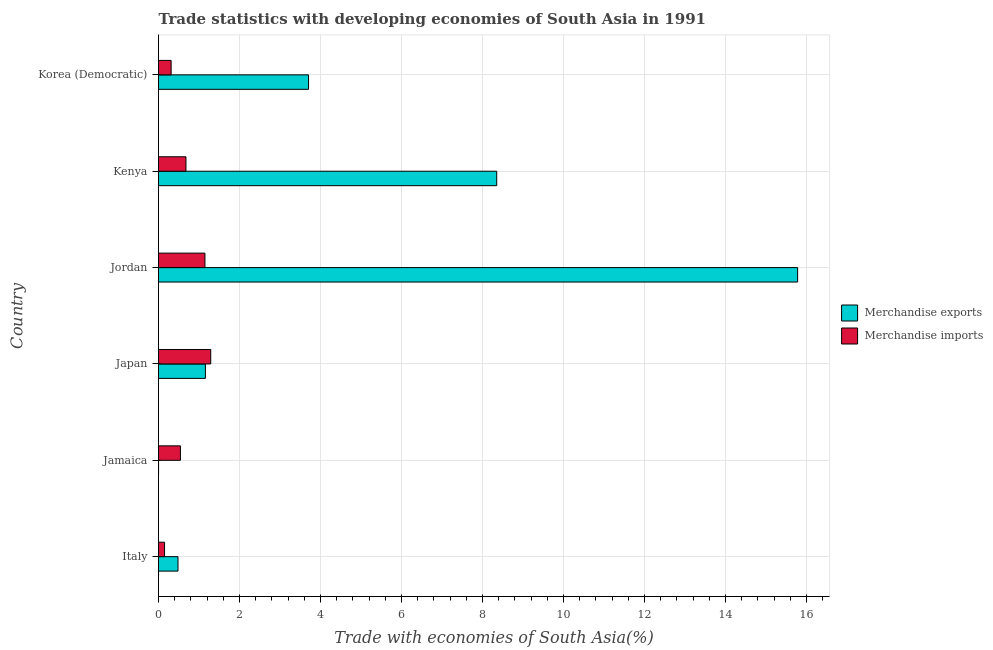How many different coloured bars are there?
Provide a succinct answer. 2. How many groups of bars are there?
Provide a succinct answer. 6. Are the number of bars on each tick of the Y-axis equal?
Your answer should be very brief. Yes. What is the label of the 4th group of bars from the top?
Your answer should be very brief. Japan. What is the merchandise exports in Jordan?
Offer a very short reply. 15.78. Across all countries, what is the maximum merchandise imports?
Your answer should be very brief. 1.29. Across all countries, what is the minimum merchandise exports?
Your answer should be very brief. 0. In which country was the merchandise imports maximum?
Give a very brief answer. Japan. In which country was the merchandise exports minimum?
Give a very brief answer. Jamaica. What is the total merchandise exports in the graph?
Your answer should be very brief. 29.48. What is the difference between the merchandise imports in Italy and that in Japan?
Offer a very short reply. -1.14. What is the difference between the merchandise exports in Japan and the merchandise imports in Italy?
Provide a succinct answer. 1.01. What is the average merchandise exports per country?
Provide a short and direct response. 4.91. What is the difference between the merchandise imports and merchandise exports in Jordan?
Offer a terse response. -14.63. What is the ratio of the merchandise exports in Jordan to that in Korea (Democratic)?
Give a very brief answer. 4.26. Is the difference between the merchandise imports in Italy and Jordan greater than the difference between the merchandise exports in Italy and Jordan?
Offer a very short reply. Yes. What is the difference between the highest and the second highest merchandise imports?
Offer a very short reply. 0.14. What is the difference between the highest and the lowest merchandise imports?
Ensure brevity in your answer.  1.14. In how many countries, is the merchandise exports greater than the average merchandise exports taken over all countries?
Make the answer very short. 2. What does the 2nd bar from the top in Jordan represents?
Keep it short and to the point. Merchandise exports. What does the 1st bar from the bottom in Kenya represents?
Offer a very short reply. Merchandise exports. How many bars are there?
Offer a terse response. 12. How many countries are there in the graph?
Keep it short and to the point. 6. Does the graph contain any zero values?
Your answer should be very brief. No. Does the graph contain grids?
Your answer should be compact. Yes. What is the title of the graph?
Give a very brief answer. Trade statistics with developing economies of South Asia in 1991. Does "Working capital" appear as one of the legend labels in the graph?
Make the answer very short. No. What is the label or title of the X-axis?
Give a very brief answer. Trade with economies of South Asia(%). What is the Trade with economies of South Asia(%) in Merchandise exports in Italy?
Make the answer very short. 0.48. What is the Trade with economies of South Asia(%) in Merchandise imports in Italy?
Your answer should be very brief. 0.15. What is the Trade with economies of South Asia(%) of Merchandise exports in Jamaica?
Provide a succinct answer. 0. What is the Trade with economies of South Asia(%) in Merchandise imports in Jamaica?
Your answer should be very brief. 0.54. What is the Trade with economies of South Asia(%) in Merchandise exports in Japan?
Offer a terse response. 1.16. What is the Trade with economies of South Asia(%) in Merchandise imports in Japan?
Offer a very short reply. 1.29. What is the Trade with economies of South Asia(%) of Merchandise exports in Jordan?
Keep it short and to the point. 15.78. What is the Trade with economies of South Asia(%) of Merchandise imports in Jordan?
Provide a succinct answer. 1.15. What is the Trade with economies of South Asia(%) of Merchandise exports in Kenya?
Ensure brevity in your answer.  8.35. What is the Trade with economies of South Asia(%) of Merchandise imports in Kenya?
Provide a succinct answer. 0.68. What is the Trade with economies of South Asia(%) in Merchandise exports in Korea (Democratic)?
Keep it short and to the point. 3.7. What is the Trade with economies of South Asia(%) of Merchandise imports in Korea (Democratic)?
Make the answer very short. 0.31. Across all countries, what is the maximum Trade with economies of South Asia(%) of Merchandise exports?
Provide a succinct answer. 15.78. Across all countries, what is the maximum Trade with economies of South Asia(%) of Merchandise imports?
Provide a succinct answer. 1.29. Across all countries, what is the minimum Trade with economies of South Asia(%) in Merchandise exports?
Offer a very short reply. 0. Across all countries, what is the minimum Trade with economies of South Asia(%) of Merchandise imports?
Offer a terse response. 0.15. What is the total Trade with economies of South Asia(%) in Merchandise exports in the graph?
Your answer should be very brief. 29.48. What is the total Trade with economies of South Asia(%) of Merchandise imports in the graph?
Keep it short and to the point. 4.11. What is the difference between the Trade with economies of South Asia(%) of Merchandise exports in Italy and that in Jamaica?
Offer a terse response. 0.48. What is the difference between the Trade with economies of South Asia(%) in Merchandise imports in Italy and that in Jamaica?
Offer a very short reply. -0.39. What is the difference between the Trade with economies of South Asia(%) of Merchandise exports in Italy and that in Japan?
Offer a terse response. -0.68. What is the difference between the Trade with economies of South Asia(%) in Merchandise imports in Italy and that in Japan?
Provide a short and direct response. -1.14. What is the difference between the Trade with economies of South Asia(%) in Merchandise exports in Italy and that in Jordan?
Provide a succinct answer. -15.3. What is the difference between the Trade with economies of South Asia(%) in Merchandise imports in Italy and that in Jordan?
Your response must be concise. -1. What is the difference between the Trade with economies of South Asia(%) in Merchandise exports in Italy and that in Kenya?
Provide a short and direct response. -7.87. What is the difference between the Trade with economies of South Asia(%) of Merchandise imports in Italy and that in Kenya?
Keep it short and to the point. -0.53. What is the difference between the Trade with economies of South Asia(%) in Merchandise exports in Italy and that in Korea (Democratic)?
Offer a very short reply. -3.22. What is the difference between the Trade with economies of South Asia(%) in Merchandise imports in Italy and that in Korea (Democratic)?
Your answer should be compact. -0.16. What is the difference between the Trade with economies of South Asia(%) in Merchandise exports in Jamaica and that in Japan?
Your answer should be compact. -1.16. What is the difference between the Trade with economies of South Asia(%) in Merchandise imports in Jamaica and that in Japan?
Give a very brief answer. -0.75. What is the difference between the Trade with economies of South Asia(%) of Merchandise exports in Jamaica and that in Jordan?
Your answer should be compact. -15.78. What is the difference between the Trade with economies of South Asia(%) of Merchandise imports in Jamaica and that in Jordan?
Ensure brevity in your answer.  -0.61. What is the difference between the Trade with economies of South Asia(%) in Merchandise exports in Jamaica and that in Kenya?
Keep it short and to the point. -8.35. What is the difference between the Trade with economies of South Asia(%) in Merchandise imports in Jamaica and that in Kenya?
Provide a short and direct response. -0.14. What is the difference between the Trade with economies of South Asia(%) of Merchandise exports in Jamaica and that in Korea (Democratic)?
Offer a very short reply. -3.7. What is the difference between the Trade with economies of South Asia(%) of Merchandise imports in Jamaica and that in Korea (Democratic)?
Keep it short and to the point. 0.23. What is the difference between the Trade with economies of South Asia(%) in Merchandise exports in Japan and that in Jordan?
Offer a very short reply. -14.62. What is the difference between the Trade with economies of South Asia(%) of Merchandise imports in Japan and that in Jordan?
Offer a very short reply. 0.14. What is the difference between the Trade with economies of South Asia(%) of Merchandise exports in Japan and that in Kenya?
Your answer should be very brief. -7.19. What is the difference between the Trade with economies of South Asia(%) in Merchandise imports in Japan and that in Kenya?
Ensure brevity in your answer.  0.61. What is the difference between the Trade with economies of South Asia(%) of Merchandise exports in Japan and that in Korea (Democratic)?
Your answer should be very brief. -2.55. What is the difference between the Trade with economies of South Asia(%) of Merchandise imports in Japan and that in Korea (Democratic)?
Your answer should be very brief. 0.98. What is the difference between the Trade with economies of South Asia(%) of Merchandise exports in Jordan and that in Kenya?
Your answer should be very brief. 7.43. What is the difference between the Trade with economies of South Asia(%) in Merchandise imports in Jordan and that in Kenya?
Make the answer very short. 0.47. What is the difference between the Trade with economies of South Asia(%) in Merchandise exports in Jordan and that in Korea (Democratic)?
Offer a very short reply. 12.08. What is the difference between the Trade with economies of South Asia(%) in Merchandise imports in Jordan and that in Korea (Democratic)?
Provide a short and direct response. 0.83. What is the difference between the Trade with economies of South Asia(%) of Merchandise exports in Kenya and that in Korea (Democratic)?
Keep it short and to the point. 4.65. What is the difference between the Trade with economies of South Asia(%) in Merchandise imports in Kenya and that in Korea (Democratic)?
Ensure brevity in your answer.  0.37. What is the difference between the Trade with economies of South Asia(%) in Merchandise exports in Italy and the Trade with economies of South Asia(%) in Merchandise imports in Jamaica?
Make the answer very short. -0.06. What is the difference between the Trade with economies of South Asia(%) of Merchandise exports in Italy and the Trade with economies of South Asia(%) of Merchandise imports in Japan?
Your response must be concise. -0.81. What is the difference between the Trade with economies of South Asia(%) in Merchandise exports in Italy and the Trade with economies of South Asia(%) in Merchandise imports in Jordan?
Ensure brevity in your answer.  -0.67. What is the difference between the Trade with economies of South Asia(%) in Merchandise exports in Italy and the Trade with economies of South Asia(%) in Merchandise imports in Kenya?
Keep it short and to the point. -0.2. What is the difference between the Trade with economies of South Asia(%) in Merchandise exports in Italy and the Trade with economies of South Asia(%) in Merchandise imports in Korea (Democratic)?
Your answer should be compact. 0.17. What is the difference between the Trade with economies of South Asia(%) of Merchandise exports in Jamaica and the Trade with economies of South Asia(%) of Merchandise imports in Japan?
Make the answer very short. -1.29. What is the difference between the Trade with economies of South Asia(%) in Merchandise exports in Jamaica and the Trade with economies of South Asia(%) in Merchandise imports in Jordan?
Offer a terse response. -1.15. What is the difference between the Trade with economies of South Asia(%) in Merchandise exports in Jamaica and the Trade with economies of South Asia(%) in Merchandise imports in Kenya?
Your answer should be very brief. -0.68. What is the difference between the Trade with economies of South Asia(%) in Merchandise exports in Jamaica and the Trade with economies of South Asia(%) in Merchandise imports in Korea (Democratic)?
Make the answer very short. -0.31. What is the difference between the Trade with economies of South Asia(%) in Merchandise exports in Japan and the Trade with economies of South Asia(%) in Merchandise imports in Jordan?
Provide a succinct answer. 0.01. What is the difference between the Trade with economies of South Asia(%) of Merchandise exports in Japan and the Trade with economies of South Asia(%) of Merchandise imports in Kenya?
Provide a short and direct response. 0.48. What is the difference between the Trade with economies of South Asia(%) of Merchandise exports in Japan and the Trade with economies of South Asia(%) of Merchandise imports in Korea (Democratic)?
Your answer should be compact. 0.85. What is the difference between the Trade with economies of South Asia(%) in Merchandise exports in Jordan and the Trade with economies of South Asia(%) in Merchandise imports in Kenya?
Keep it short and to the point. 15.1. What is the difference between the Trade with economies of South Asia(%) of Merchandise exports in Jordan and the Trade with economies of South Asia(%) of Merchandise imports in Korea (Democratic)?
Your answer should be very brief. 15.47. What is the difference between the Trade with economies of South Asia(%) of Merchandise exports in Kenya and the Trade with economies of South Asia(%) of Merchandise imports in Korea (Democratic)?
Offer a terse response. 8.04. What is the average Trade with economies of South Asia(%) in Merchandise exports per country?
Your answer should be very brief. 4.91. What is the average Trade with economies of South Asia(%) of Merchandise imports per country?
Your answer should be very brief. 0.69. What is the difference between the Trade with economies of South Asia(%) of Merchandise exports and Trade with economies of South Asia(%) of Merchandise imports in Italy?
Keep it short and to the point. 0.33. What is the difference between the Trade with economies of South Asia(%) in Merchandise exports and Trade with economies of South Asia(%) in Merchandise imports in Jamaica?
Offer a very short reply. -0.54. What is the difference between the Trade with economies of South Asia(%) in Merchandise exports and Trade with economies of South Asia(%) in Merchandise imports in Japan?
Offer a terse response. -0.13. What is the difference between the Trade with economies of South Asia(%) of Merchandise exports and Trade with economies of South Asia(%) of Merchandise imports in Jordan?
Your response must be concise. 14.63. What is the difference between the Trade with economies of South Asia(%) in Merchandise exports and Trade with economies of South Asia(%) in Merchandise imports in Kenya?
Offer a very short reply. 7.67. What is the difference between the Trade with economies of South Asia(%) in Merchandise exports and Trade with economies of South Asia(%) in Merchandise imports in Korea (Democratic)?
Offer a very short reply. 3.39. What is the ratio of the Trade with economies of South Asia(%) of Merchandise exports in Italy to that in Jamaica?
Offer a very short reply. 537.4. What is the ratio of the Trade with economies of South Asia(%) of Merchandise imports in Italy to that in Jamaica?
Provide a succinct answer. 0.28. What is the ratio of the Trade with economies of South Asia(%) in Merchandise exports in Italy to that in Japan?
Your response must be concise. 0.42. What is the ratio of the Trade with economies of South Asia(%) of Merchandise imports in Italy to that in Japan?
Your answer should be very brief. 0.12. What is the ratio of the Trade with economies of South Asia(%) of Merchandise exports in Italy to that in Jordan?
Provide a succinct answer. 0.03. What is the ratio of the Trade with economies of South Asia(%) of Merchandise imports in Italy to that in Jordan?
Provide a succinct answer. 0.13. What is the ratio of the Trade with economies of South Asia(%) in Merchandise exports in Italy to that in Kenya?
Offer a terse response. 0.06. What is the ratio of the Trade with economies of South Asia(%) of Merchandise imports in Italy to that in Kenya?
Make the answer very short. 0.22. What is the ratio of the Trade with economies of South Asia(%) of Merchandise exports in Italy to that in Korea (Democratic)?
Provide a short and direct response. 0.13. What is the ratio of the Trade with economies of South Asia(%) of Merchandise imports in Italy to that in Korea (Democratic)?
Offer a terse response. 0.48. What is the ratio of the Trade with economies of South Asia(%) of Merchandise exports in Jamaica to that in Japan?
Offer a very short reply. 0. What is the ratio of the Trade with economies of South Asia(%) of Merchandise imports in Jamaica to that in Japan?
Make the answer very short. 0.42. What is the ratio of the Trade with economies of South Asia(%) in Merchandise exports in Jamaica to that in Jordan?
Provide a succinct answer. 0. What is the ratio of the Trade with economies of South Asia(%) of Merchandise imports in Jamaica to that in Jordan?
Your response must be concise. 0.47. What is the ratio of the Trade with economies of South Asia(%) in Merchandise exports in Jamaica to that in Kenya?
Ensure brevity in your answer.  0. What is the ratio of the Trade with economies of South Asia(%) of Merchandise imports in Jamaica to that in Kenya?
Make the answer very short. 0.8. What is the ratio of the Trade with economies of South Asia(%) in Merchandise imports in Jamaica to that in Korea (Democratic)?
Your answer should be compact. 1.74. What is the ratio of the Trade with economies of South Asia(%) of Merchandise exports in Japan to that in Jordan?
Keep it short and to the point. 0.07. What is the ratio of the Trade with economies of South Asia(%) in Merchandise imports in Japan to that in Jordan?
Give a very brief answer. 1.12. What is the ratio of the Trade with economies of South Asia(%) of Merchandise exports in Japan to that in Kenya?
Give a very brief answer. 0.14. What is the ratio of the Trade with economies of South Asia(%) in Merchandise imports in Japan to that in Kenya?
Ensure brevity in your answer.  1.9. What is the ratio of the Trade with economies of South Asia(%) in Merchandise exports in Japan to that in Korea (Democratic)?
Keep it short and to the point. 0.31. What is the ratio of the Trade with economies of South Asia(%) of Merchandise imports in Japan to that in Korea (Democratic)?
Provide a short and direct response. 4.14. What is the ratio of the Trade with economies of South Asia(%) in Merchandise exports in Jordan to that in Kenya?
Ensure brevity in your answer.  1.89. What is the ratio of the Trade with economies of South Asia(%) in Merchandise imports in Jordan to that in Kenya?
Give a very brief answer. 1.69. What is the ratio of the Trade with economies of South Asia(%) in Merchandise exports in Jordan to that in Korea (Democratic)?
Your response must be concise. 4.26. What is the ratio of the Trade with economies of South Asia(%) of Merchandise imports in Jordan to that in Korea (Democratic)?
Your response must be concise. 3.68. What is the ratio of the Trade with economies of South Asia(%) in Merchandise exports in Kenya to that in Korea (Democratic)?
Your answer should be compact. 2.25. What is the ratio of the Trade with economies of South Asia(%) in Merchandise imports in Kenya to that in Korea (Democratic)?
Your response must be concise. 2.18. What is the difference between the highest and the second highest Trade with economies of South Asia(%) in Merchandise exports?
Ensure brevity in your answer.  7.43. What is the difference between the highest and the second highest Trade with economies of South Asia(%) in Merchandise imports?
Offer a terse response. 0.14. What is the difference between the highest and the lowest Trade with economies of South Asia(%) of Merchandise exports?
Ensure brevity in your answer.  15.78. What is the difference between the highest and the lowest Trade with economies of South Asia(%) in Merchandise imports?
Your response must be concise. 1.14. 